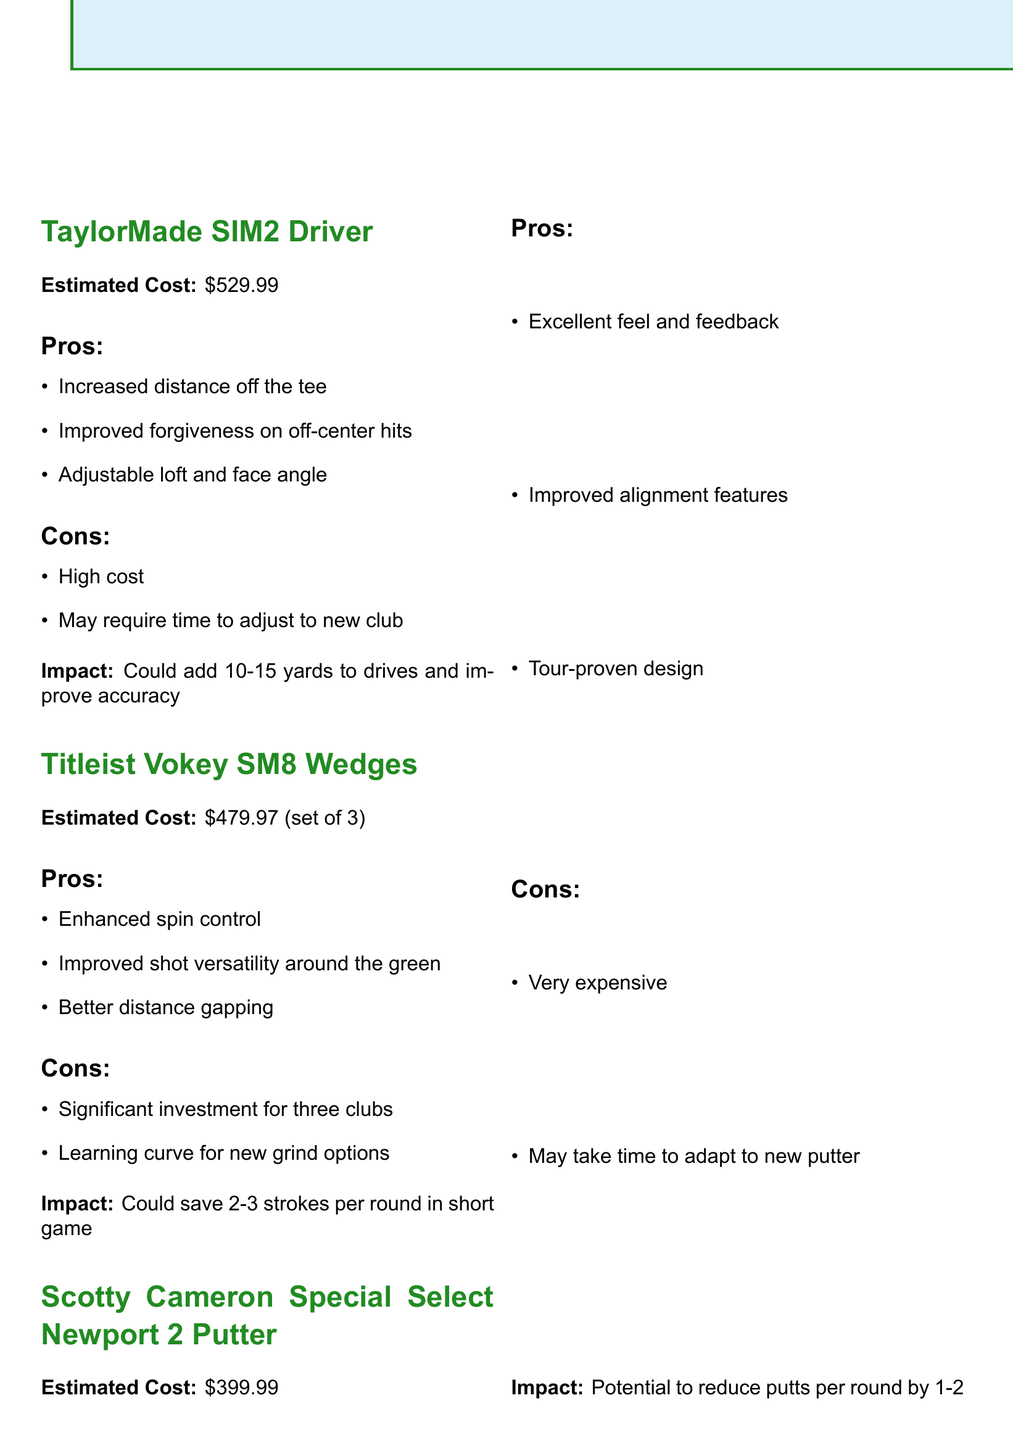What is the cost of the TaylorMade SIM2 Driver? The estimated cost for the TaylorMade SIM2 Driver is mentioned in the document as $529.99.
Answer: $529.99 How many wedges are included in the Titleist Vokey SM8 set? The document states that the Titleist Vokey SM8 Wedges include three clubs.
Answer: Three What is one pro of the FootJoy Pro SL Carbon Golf Shoes? The document lists multiple pros for the FootJoy Pro SL Carbon Golf Shoes, such as enhanced stability during the swing.
Answer: Enhanced stability What is the potential impact of upgrading to the Scotty Cameron Special Select Newport 2 Putter? The document mentions that the upgrade could potentially reduce putts per round by 1-2.
Answer: 1-2 What is a con for the Bushnell Pro XE Rangefinder? The document presents cons for the Bushnell Pro XE Rangefinder, including its high price point.
Answer: High price point Estimate the total cost of the Titleist Vokey SM8 Wedges. The document notes the cost for each wedge is $159.99, and with three wedges, the total cost is $479.97.
Answer: $479.97 What feature does the TaylorMade SIM2 Driver have? The document highlights that the driver has adjustable loft and face angle as a feature.
Answer: Adjustable loft and face angle Which item has waterproof protection? The FootJoy Pro SL Carbon Golf Shoes are noted for having waterproof protection in the document.
Answer: FootJoy Pro SL Carbon Golf Shoes 